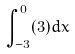<formula> <loc_0><loc_0><loc_500><loc_500>\int _ { - 3 } ^ { 0 } ( 3 ) d x</formula> 